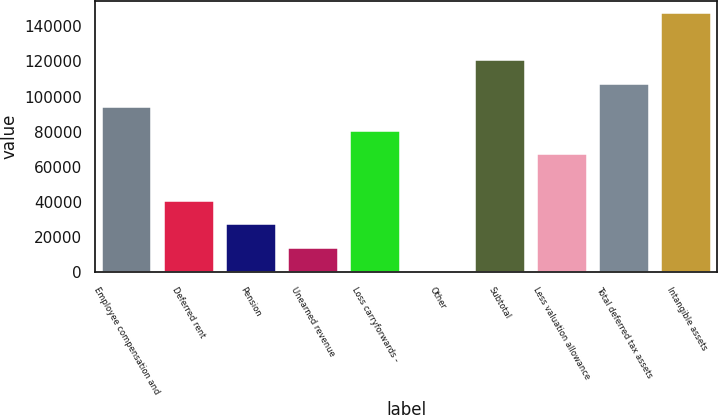Convert chart. <chart><loc_0><loc_0><loc_500><loc_500><bar_chart><fcel>Employee compensation and<fcel>Deferred rent<fcel>Pension<fcel>Unearned revenue<fcel>Loss carryforwards -<fcel>Other<fcel>Subtotal<fcel>Less valuation allowance<fcel>Total deferred tax assets<fcel>Intangible assets<nl><fcel>93948.5<fcel>40582.5<fcel>27241<fcel>13899.5<fcel>80607<fcel>558<fcel>120632<fcel>67265.5<fcel>107290<fcel>147314<nl></chart> 